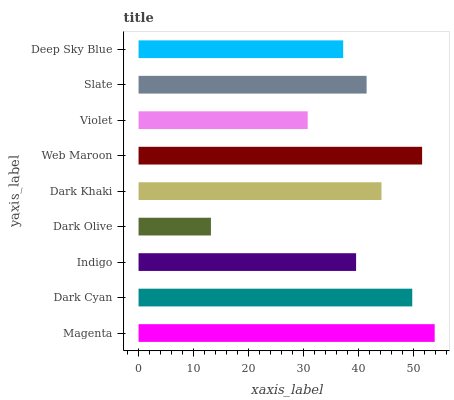Is Dark Olive the minimum?
Answer yes or no. Yes. Is Magenta the maximum?
Answer yes or no. Yes. Is Dark Cyan the minimum?
Answer yes or no. No. Is Dark Cyan the maximum?
Answer yes or no. No. Is Magenta greater than Dark Cyan?
Answer yes or no. Yes. Is Dark Cyan less than Magenta?
Answer yes or no. Yes. Is Dark Cyan greater than Magenta?
Answer yes or no. No. Is Magenta less than Dark Cyan?
Answer yes or no. No. Is Slate the high median?
Answer yes or no. Yes. Is Slate the low median?
Answer yes or no. Yes. Is Dark Khaki the high median?
Answer yes or no. No. Is Magenta the low median?
Answer yes or no. No. 